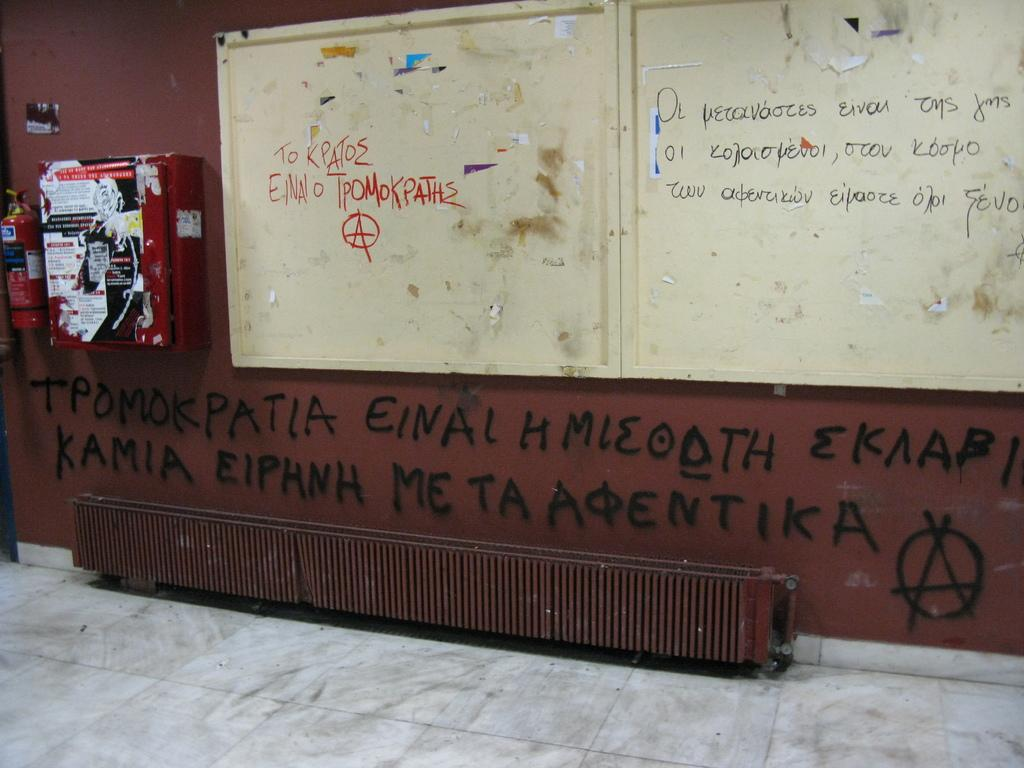<image>
Summarize the visual content of the image. A wall covered in graffiti some of which says KAMIA EIPHNH. 